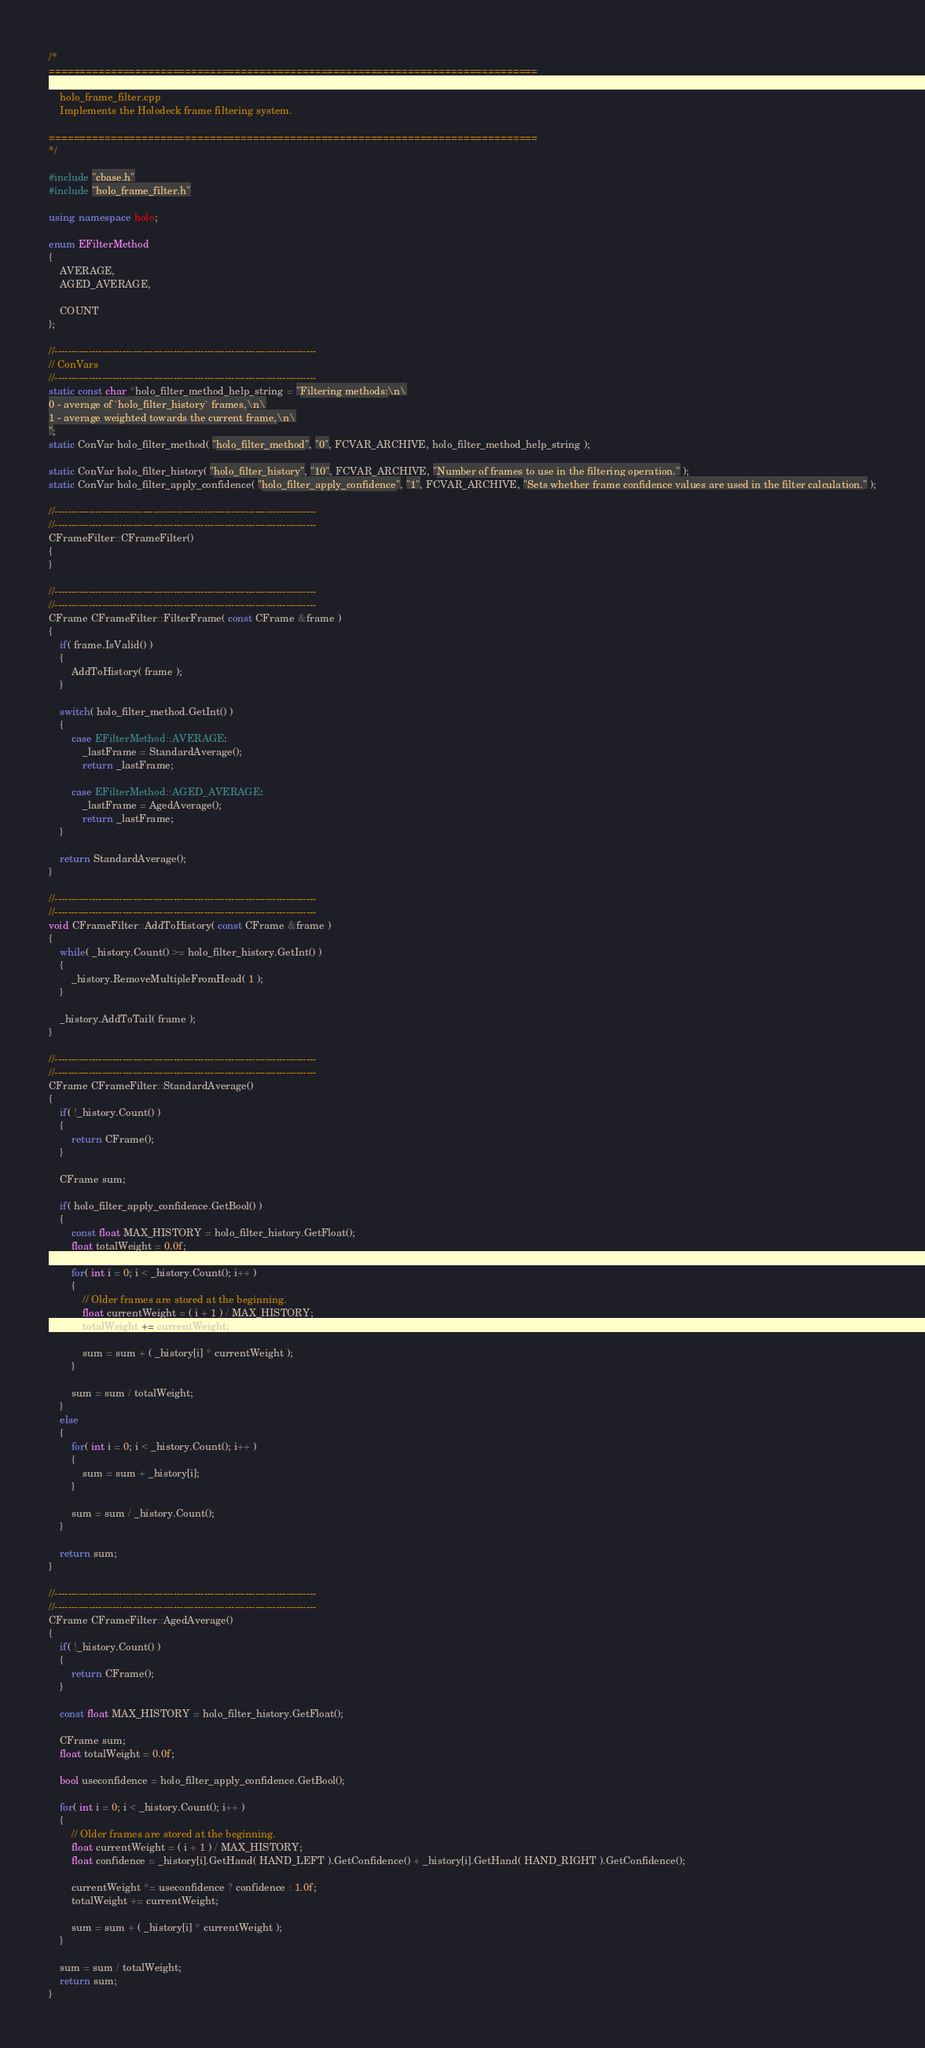Convert code to text. <code><loc_0><loc_0><loc_500><loc_500><_C++_>/*
===============================================================================

	holo_frame_filter.cpp
	Implements the Holodeck frame filtering system.

===============================================================================
*/

#include "cbase.h"
#include "holo_frame_filter.h"

using namespace holo;

enum EFilterMethod
{
	AVERAGE,
	AGED_AVERAGE,

	COUNT
};

//-----------------------------------------------------------------------------
// ConVars
//-----------------------------------------------------------------------------
static const char *holo_filter_method_help_string = "Filtering methods:\n\
0 - average of `holo_filter_history` frames,\n\
1 - average weighted towards the current frame,\n\
";
static ConVar holo_filter_method( "holo_filter_method", "0", FCVAR_ARCHIVE, holo_filter_method_help_string );

static ConVar holo_filter_history( "holo_filter_history", "10", FCVAR_ARCHIVE, "Number of frames to use in the filtering operation." );
static ConVar holo_filter_apply_confidence( "holo_filter_apply_confidence", "1", FCVAR_ARCHIVE, "Sets whether frame confidence values are used in the filter calculation." );

//-----------------------------------------------------------------------------
//-----------------------------------------------------------------------------
CFrameFilter::CFrameFilter()
{
}

//-----------------------------------------------------------------------------
//-----------------------------------------------------------------------------
CFrame CFrameFilter::FilterFrame( const CFrame &frame )
{
	if( frame.IsValid() )
	{
		AddToHistory( frame );
	}

	switch( holo_filter_method.GetInt() )
	{
		case EFilterMethod::AVERAGE:
			_lastFrame = StandardAverage();
			return _lastFrame;

		case EFilterMethod::AGED_AVERAGE:
			_lastFrame = AgedAverage();
			return _lastFrame;
	}

	return StandardAverage();
}

//-----------------------------------------------------------------------------
//-----------------------------------------------------------------------------
void CFrameFilter::AddToHistory( const CFrame &frame )
{
	while( _history.Count() >= holo_filter_history.GetInt() )
	{
		_history.RemoveMultipleFromHead( 1 );
	}
		
	_history.AddToTail( frame );
}

//-----------------------------------------------------------------------------
//-----------------------------------------------------------------------------
CFrame CFrameFilter::StandardAverage()
{
	if( !_history.Count() )
	{
		return CFrame();
	}

	CFrame sum;

	if( holo_filter_apply_confidence.GetBool() )
	{
		const float MAX_HISTORY = holo_filter_history.GetFloat();
		float totalWeight = 0.0f;

		for( int i = 0; i < _history.Count(); i++ )
		{
			// Older frames are stored at the beginning.
			float currentWeight = ( i + 1 ) / MAX_HISTORY;
			totalWeight += currentWeight;

			sum = sum + ( _history[i] * currentWeight );
		}

		sum = sum / totalWeight;
	}
	else
	{
		for( int i = 0; i < _history.Count(); i++ )
		{
			sum = sum + _history[i];
		}

		sum = sum / _history.Count();
	}	

	return sum;
}

//-----------------------------------------------------------------------------
//-----------------------------------------------------------------------------
CFrame CFrameFilter::AgedAverage()
{
	if( !_history.Count() )
	{
		return CFrame();
	}

	const float MAX_HISTORY = holo_filter_history.GetFloat();

	CFrame sum;
	float totalWeight = 0.0f;

	bool useconfidence = holo_filter_apply_confidence.GetBool();

	for( int i = 0; i < _history.Count(); i++ )
	{
		// Older frames are stored at the beginning.
		float currentWeight = ( i + 1 ) / MAX_HISTORY;
		float confidence = _history[i].GetHand( HAND_LEFT ).GetConfidence() + _history[i].GetHand( HAND_RIGHT ).GetConfidence();

		currentWeight *= useconfidence ? confidence : 1.0f;
		totalWeight += currentWeight;

		sum = sum + ( _history[i] * currentWeight );
	}

	sum = sum / totalWeight;
	return sum;
}</code> 